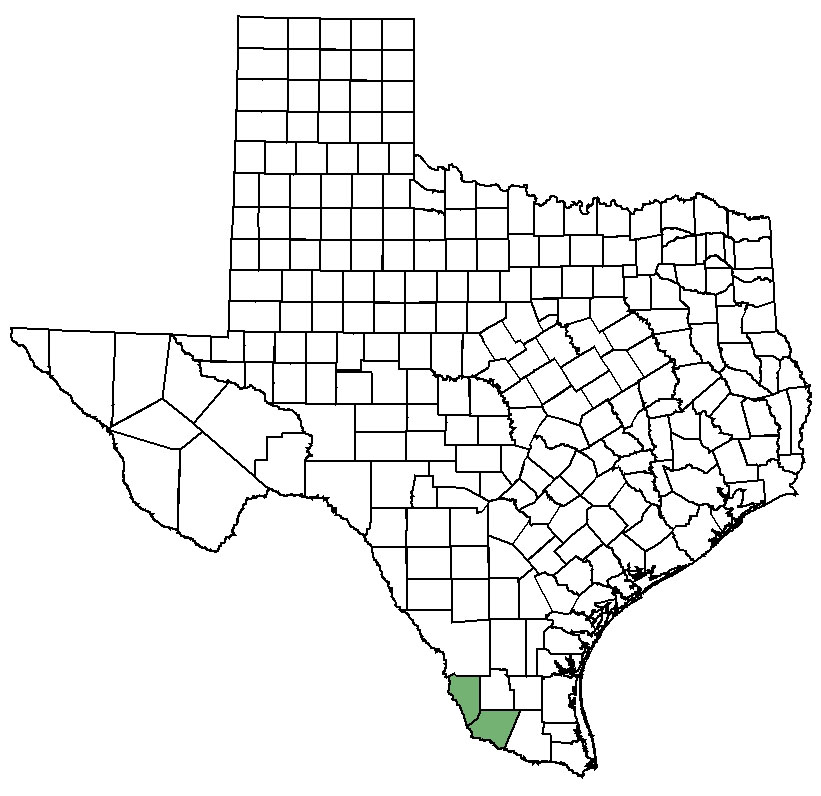What historical significance does the highlighted county have? The highlighted county in southern Texas is renowned for its rich cultural and historical heritage. It has been a critical area in Texan history, influenced by Spanish exploration, Mexican rule, and ultimately becoming part of Texas. Historically, this region has seen significant events such as battles, migrations, and economic development, especially in agriculture and trade. Specific landmarks and sites continue to draw interest and tourism, reflecting its deep historical roots. 